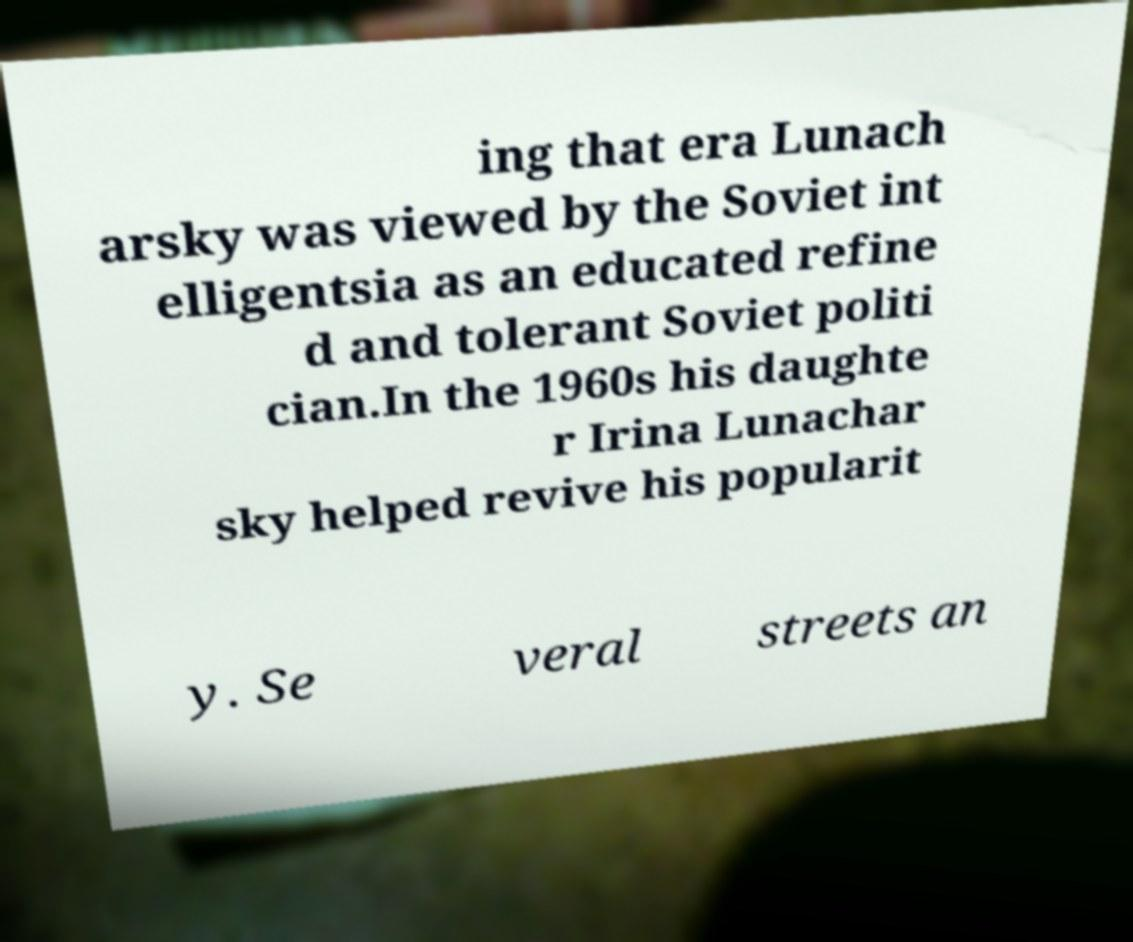What messages or text are displayed in this image? I need them in a readable, typed format. ing that era Lunach arsky was viewed by the Soviet int elligentsia as an educated refine d and tolerant Soviet politi cian.In the 1960s his daughte r Irina Lunachar sky helped revive his popularit y. Se veral streets an 